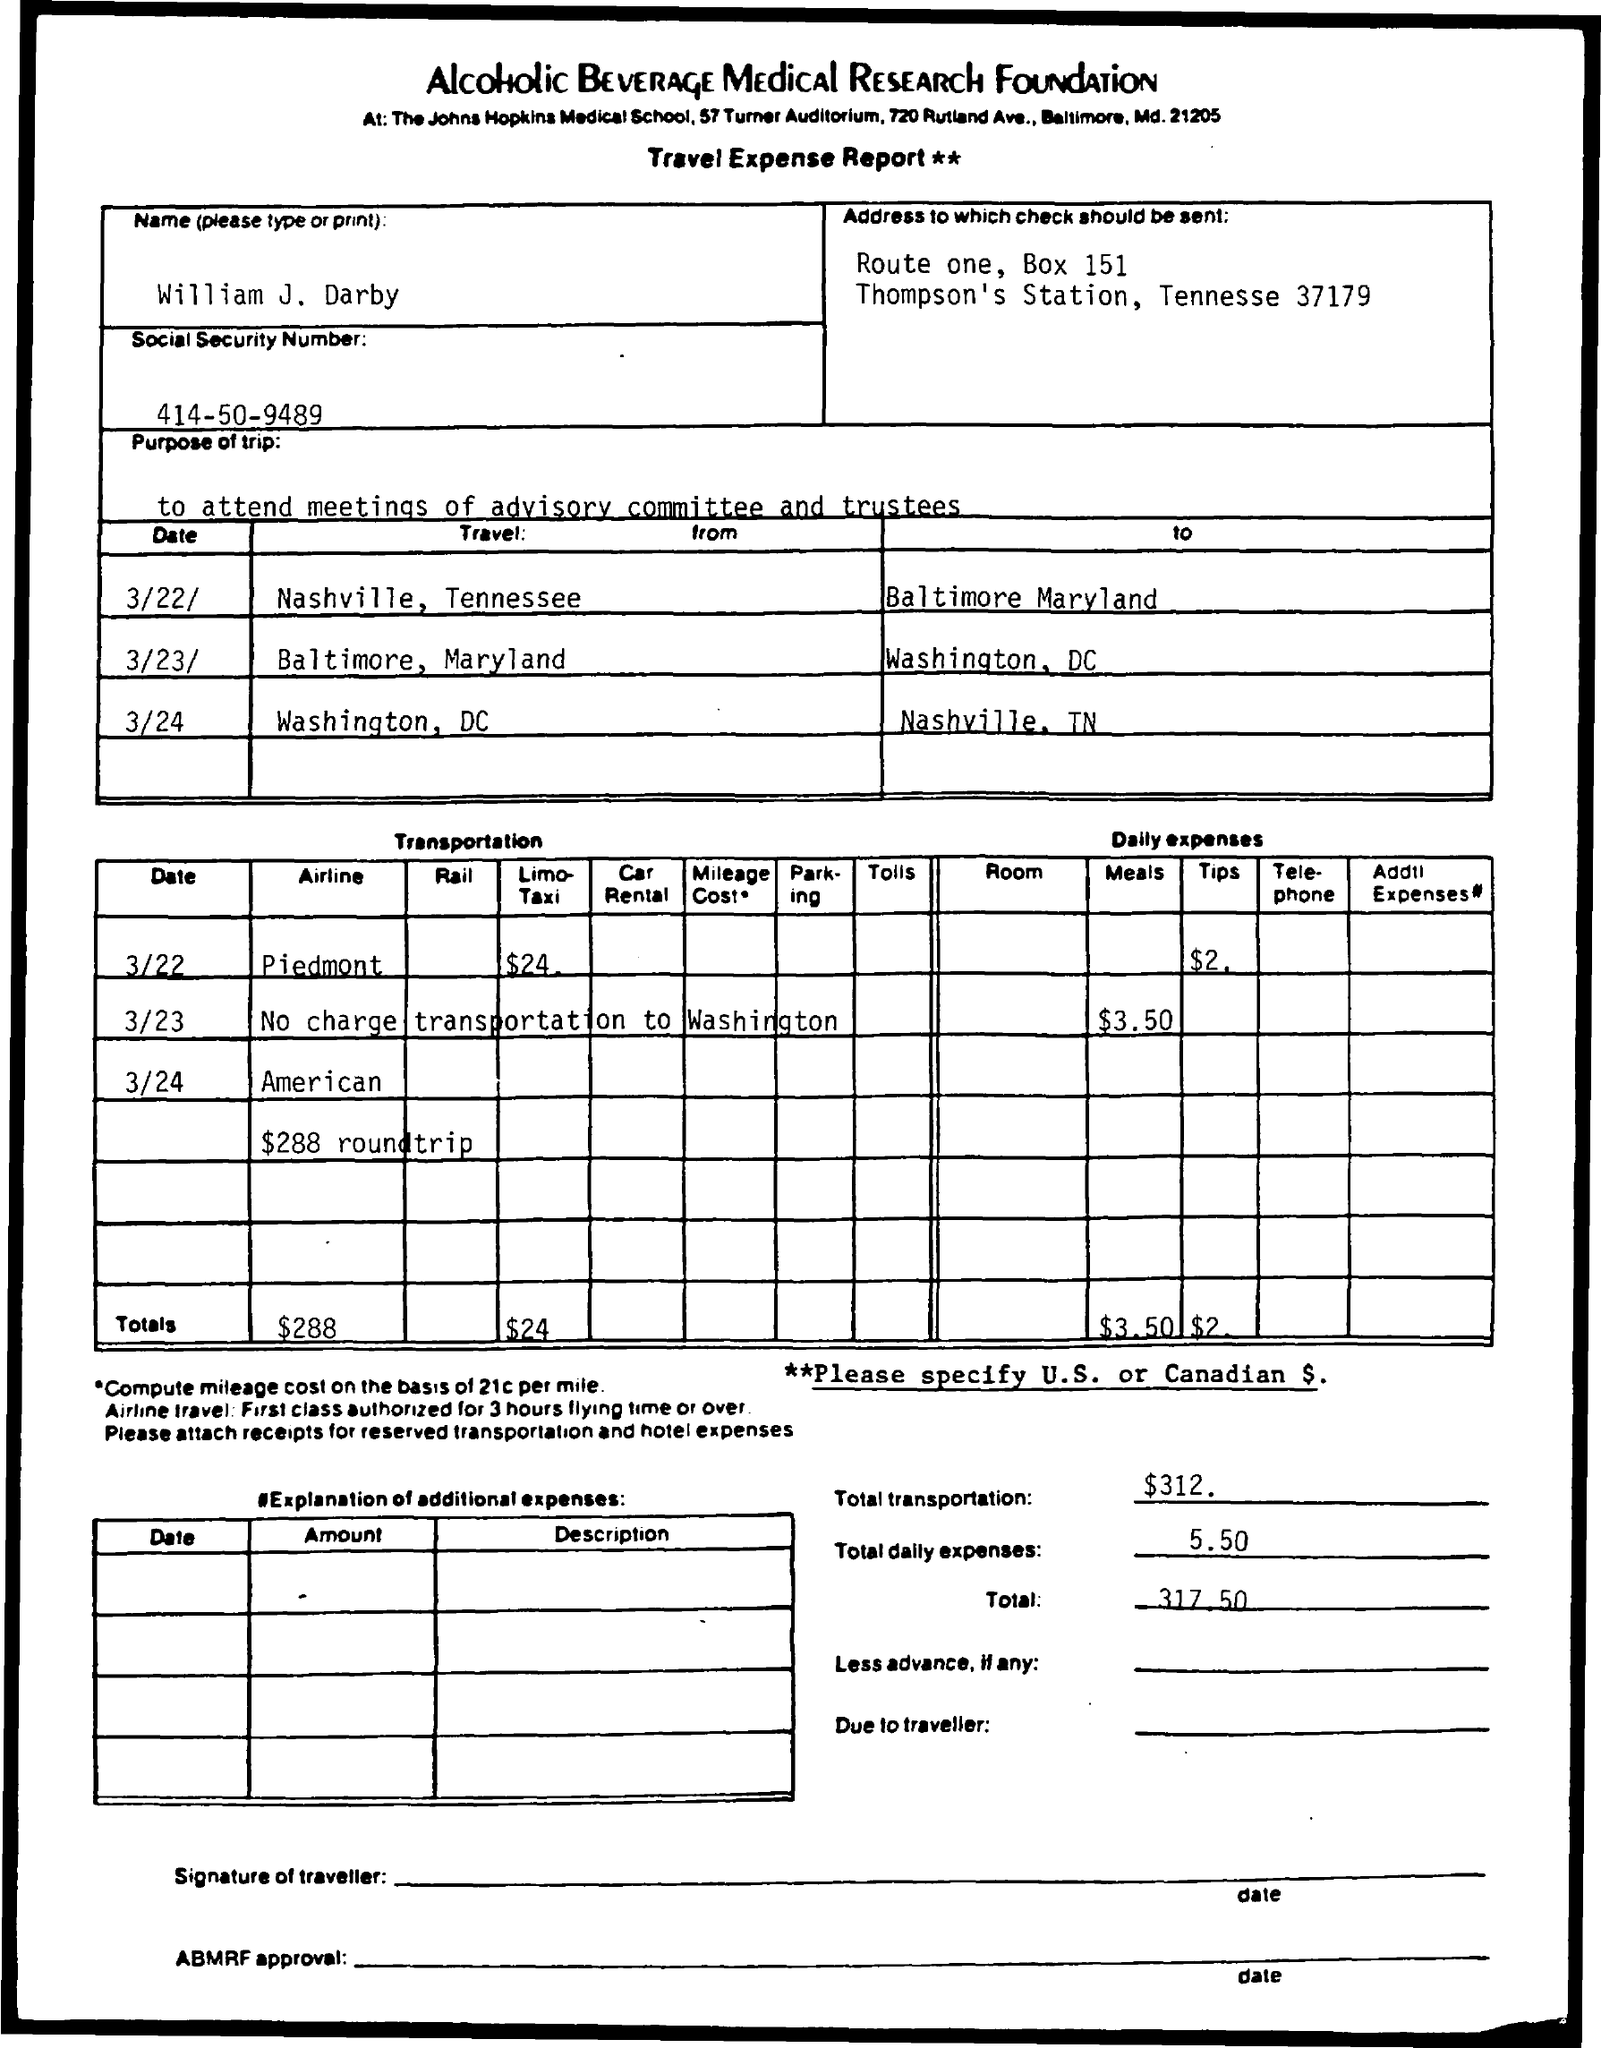Which report is mentioned in the document?
Your answer should be very brief. Travel Expense Report. What is the foundation name mentioned in the document?
Make the answer very short. Alcoholic beverage medical research foundation. What is the purpose of trip mentioned in the document?
Provide a short and direct response. To attend meetings of advisory committee and trustees. What is the social security number mentioned in the document?
Offer a very short reply. 414-50-9489. What is the total transportation amount mentioned in the document?
Offer a very short reply. $312. What is the condition mentioned in double star marks?
Give a very brief answer. Please specify U.S. or Canadian $. 